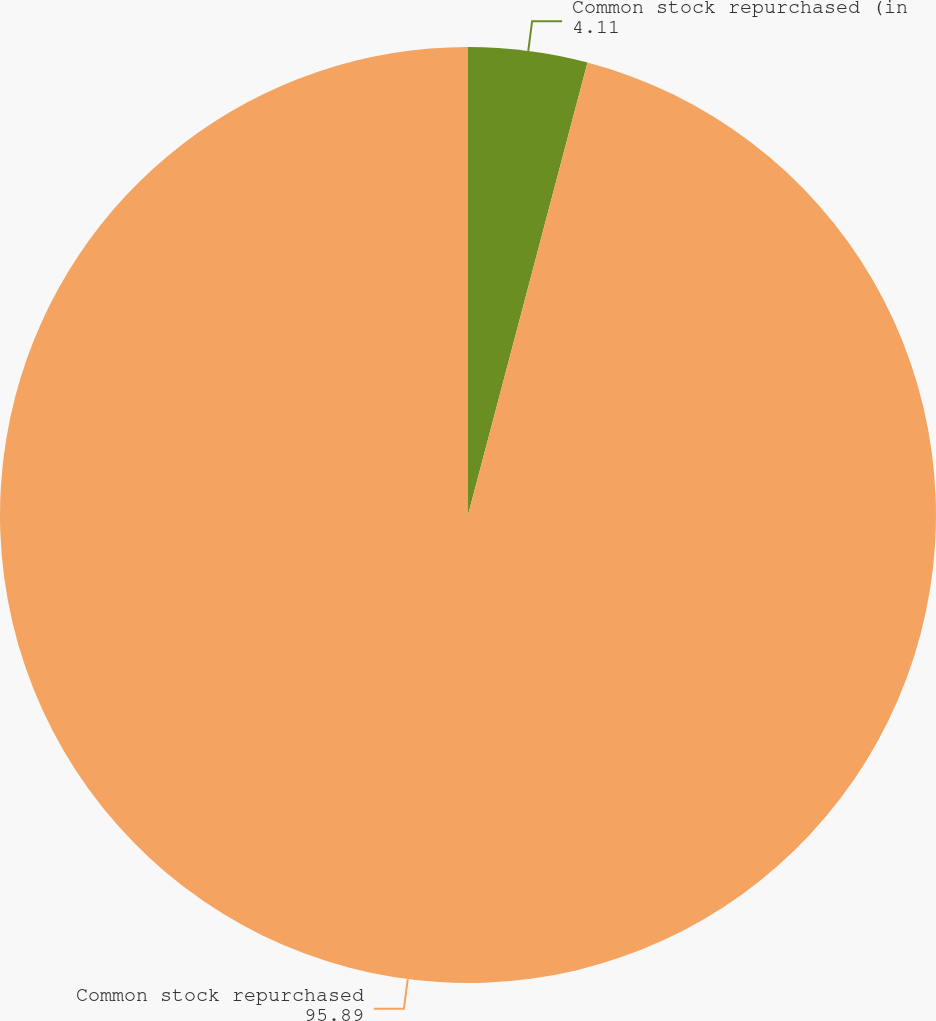<chart> <loc_0><loc_0><loc_500><loc_500><pie_chart><fcel>Common stock repurchased (in<fcel>Common stock repurchased<nl><fcel>4.11%<fcel>95.89%<nl></chart> 